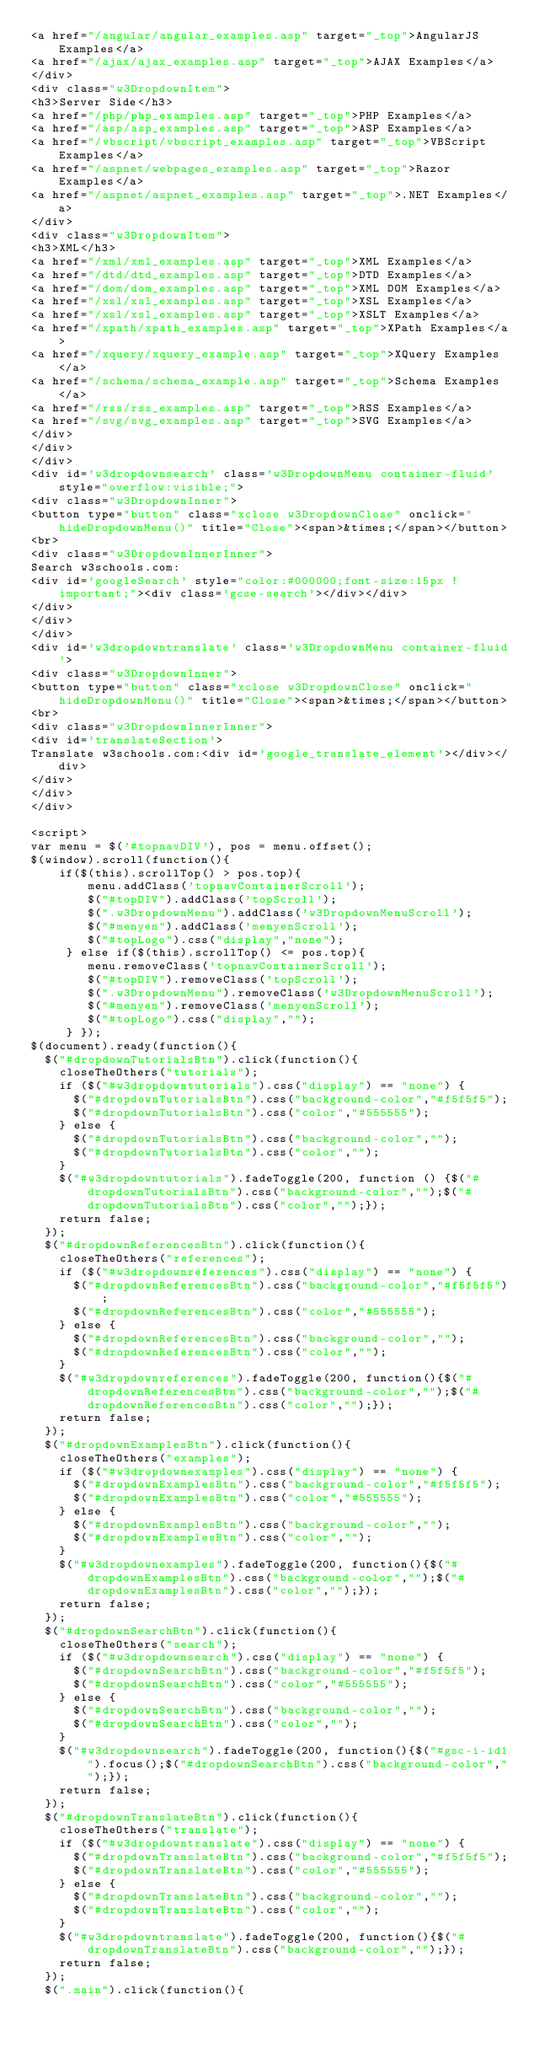<code> <loc_0><loc_0><loc_500><loc_500><_HTML_><a href="/angular/angular_examples.asp" target="_top">AngularJS Examples</a>
<a href="/ajax/ajax_examples.asp" target="_top">AJAX Examples</a>
</div>
<div class="w3DropdownItem">
<h3>Server Side</h3>
<a href="/php/php_examples.asp" target="_top">PHP Examples</a>
<a href="/asp/asp_examples.asp" target="_top">ASP Examples</a>
<a href="/vbscript/vbscript_examples.asp" target="_top">VBScript Examples</a>
<a href="/aspnet/webpages_examples.asp" target="_top">Razor Examples</a>
<a href="/aspnet/aspnet_examples.asp" target="_top">.NET Examples</a>
</div>
<div class="w3DropdownItem">
<h3>XML</h3>
<a href="/xml/xml_examples.asp" target="_top">XML Examples</a>
<a href="/dtd/dtd_examples.asp" target="_top">DTD Examples</a>
<a href="/dom/dom_examples.asp" target="_top">XML DOM Examples</a>
<a href="/xsl/xsl_examples.asp" target="_top">XSL Examples</a>
<a href="/xsl/xsl_examples.asp" target="_top">XSLT Examples</a>
<a href="/xpath/xpath_examples.asp" target="_top">XPath Examples</a>
<a href="/xquery/xquery_example.asp" target="_top">XQuery Examples</a>
<a href="/schema/schema_example.asp" target="_top">Schema Examples</a>
<a href="/rss/rss_examples.asp" target="_top">RSS Examples</a>
<a href="/svg/svg_examples.asp" target="_top">SVG Examples</a>
</div>
</div>
</div>
<div id='w3dropdownsearch' class='w3DropdownMenu container-fluid' style="overflow:visible;">
<div class="w3DropdownInner">
<button type="button" class="xclose w3DropdownClose" onclick="hideDropdownMenu()" title="Close"><span>&times;</span></button>
<br>
<div class="w3DropdownInnerInner">
Search w3schools.com:
<div id='googleSearch' style="color:#000000;font-size:15px !important;"><div class='gcse-search'></div></div>
</div>
</div>
</div>
<div id='w3dropdowntranslate' class='w3DropdownMenu container-fluid'>
<div class="w3DropdownInner">
<button type="button" class="xclose w3DropdownClose" onclick="hideDropdownMenu()" title="Close"><span>&times;</span></button>
<br>
<div class="w3DropdownInnerInner">
<div id='translateSection'>
Translate w3schools.com:<div id='google_translate_element'></div></div>
</div>
</div>
</div>

<script>
var menu = $('#topnavDIV'), pos = menu.offset();
$(window).scroll(function(){
    if($(this).scrollTop() > pos.top){
        menu.addClass('topnavContainerScroll');        
        $("#topDIV").addClass('topScroll');
        $(".w3DropdownMenu").addClass('w3DropdownMenuScroll');        
        $("#menyen").addClass('menyenScroll');
        $("#topLogo").css("display","none");
     } else if($(this).scrollTop() <= pos.top){
        menu.removeClass('topnavContainerScroll');
        $("#topDIV").removeClass('topScroll');
        $(".w3DropdownMenu").removeClass('w3DropdownMenuScroll');
        $("#menyen").removeClass('menyenScroll');
        $("#topLogo").css("display","");
     } });
$(document).ready(function(){
  $("#dropdownTutorialsBtn").click(function(){
    closeTheOthers("tutorials");
    if ($("#w3dropdowntutorials").css("display") == "none") {
      $("#dropdownTutorialsBtn").css("background-color","#f5f5f5");
      $("#dropdownTutorialsBtn").css("color","#555555");
    } else {
      $("#dropdownTutorialsBtn").css("background-color","");
      $("#dropdownTutorialsBtn").css("color","");
    }
    $("#w3dropdowntutorials").fadeToggle(200, function () {$("#dropdownTutorialsBtn").css("background-color","");$("#dropdownTutorialsBtn").css("color","");});
    return false;      
  });
  $("#dropdownReferencesBtn").click(function(){
    closeTheOthers("references");
    if ($("#w3dropdownreferences").css("display") == "none") {
      $("#dropdownReferencesBtn").css("background-color","#f5f5f5");
      $("#dropdownReferencesBtn").css("color","#555555");
    } else {
      $("#dropdownReferencesBtn").css("background-color","");
      $("#dropdownReferencesBtn").css("color","");
    }
    $("#w3dropdownreferences").fadeToggle(200, function(){$("#dropdownReferencesBtn").css("background-color","");$("#dropdownReferencesBtn").css("color","");});
    return false;      
  });
  $("#dropdownExamplesBtn").click(function(){
    closeTheOthers("examples");
    if ($("#w3dropdownexamples").css("display") == "none") {
      $("#dropdownExamplesBtn").css("background-color","#f5f5f5");
      $("#dropdownExamplesBtn").css("color","#555555");
    } else {
      $("#dropdownExamplesBtn").css("background-color","");
      $("#dropdownExamplesBtn").css("color","");
    }
    $("#w3dropdownexamples").fadeToggle(200, function(){$("#dropdownExamplesBtn").css("background-color","");$("#dropdownExamplesBtn").css("color","");});
    return false;      
  });
  $("#dropdownSearchBtn").click(function(){
    closeTheOthers("search");
    if ($("#w3dropdownsearch").css("display") == "none") {
      $("#dropdownSearchBtn").css("background-color","#f5f5f5");
      $("#dropdownSearchBtn").css("color","#555555");
    } else {
      $("#dropdownSearchBtn").css("background-color","");
      $("#dropdownSearchBtn").css("color","");
    }
    $("#w3dropdownsearch").fadeToggle(200, function(){$("#gsc-i-id1").focus();$("#dropdownSearchBtn").css("background-color","");});
    return false;      
  });
  $("#dropdownTranslateBtn").click(function(){
    closeTheOthers("translate");
    if ($("#w3dropdowntranslate").css("display") == "none") {
      $("#dropdownTranslateBtn").css("background-color","#f5f5f5");
      $("#dropdownTranslateBtn").css("color","#555555");
    } else {
      $("#dropdownTranslateBtn").css("background-color","");
      $("#dropdownTranslateBtn").css("color","");
    }
    $("#w3dropdowntranslate").fadeToggle(200, function(){$("#dropdownTranslateBtn").css("background-color","");});
    return false;      
  });
  $(".main").click(function(){</code> 